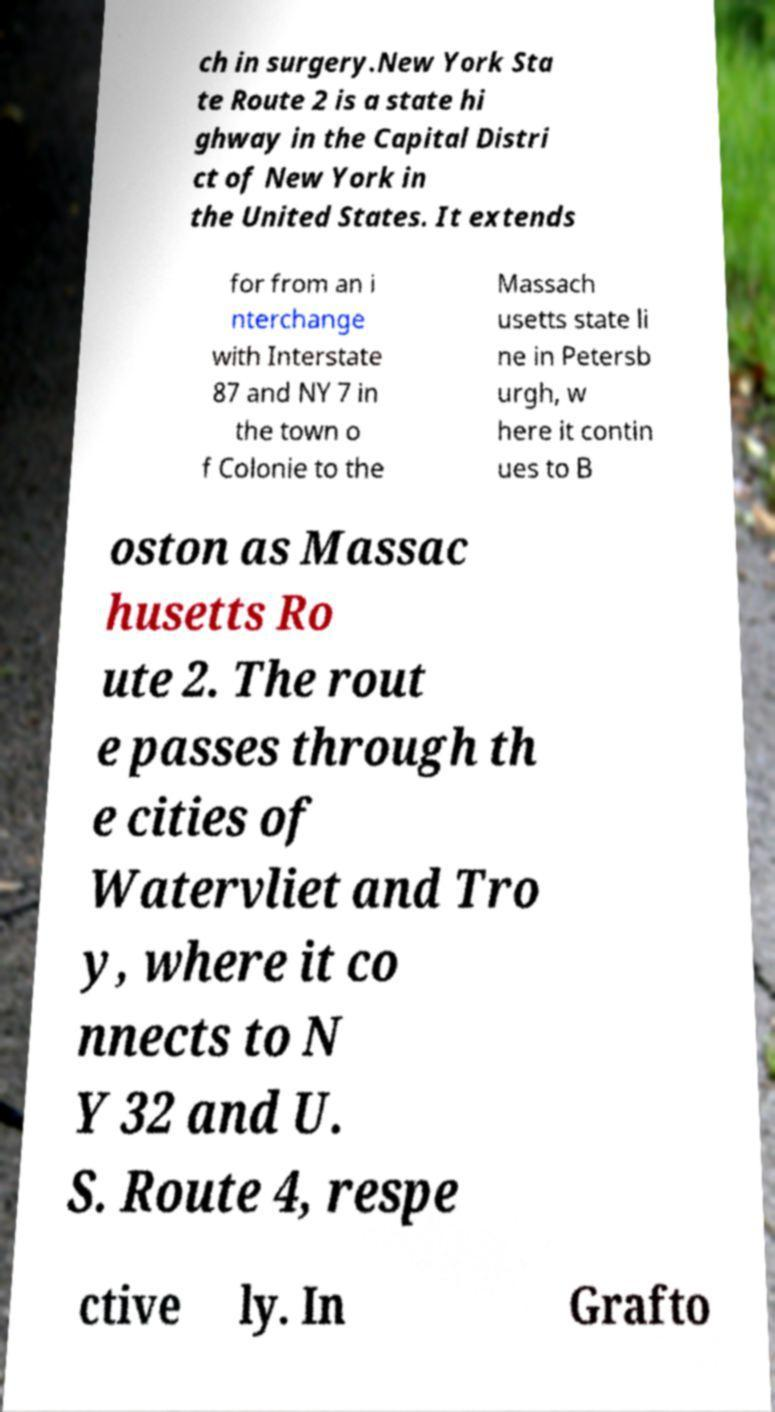Can you accurately transcribe the text from the provided image for me? ch in surgery.New York Sta te Route 2 is a state hi ghway in the Capital Distri ct of New York in the United States. It extends for from an i nterchange with Interstate 87 and NY 7 in the town o f Colonie to the Massach usetts state li ne in Petersb urgh, w here it contin ues to B oston as Massac husetts Ro ute 2. The rout e passes through th e cities of Watervliet and Tro y, where it co nnects to N Y 32 and U. S. Route 4, respe ctive ly. In Grafto 